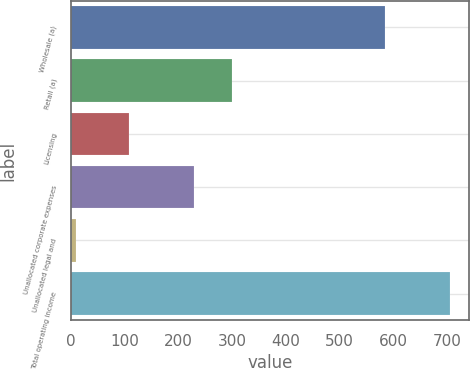Convert chart to OTSL. <chart><loc_0><loc_0><loc_500><loc_500><bar_chart><fcel>Wholesale (a)<fcel>Retail (a)<fcel>Licensing<fcel>Unallocated corporate expenses<fcel>Unallocated legal and<fcel>Total operating income<nl><fcel>585.3<fcel>299.59<fcel>107.4<fcel>229.9<fcel>10<fcel>706.9<nl></chart> 